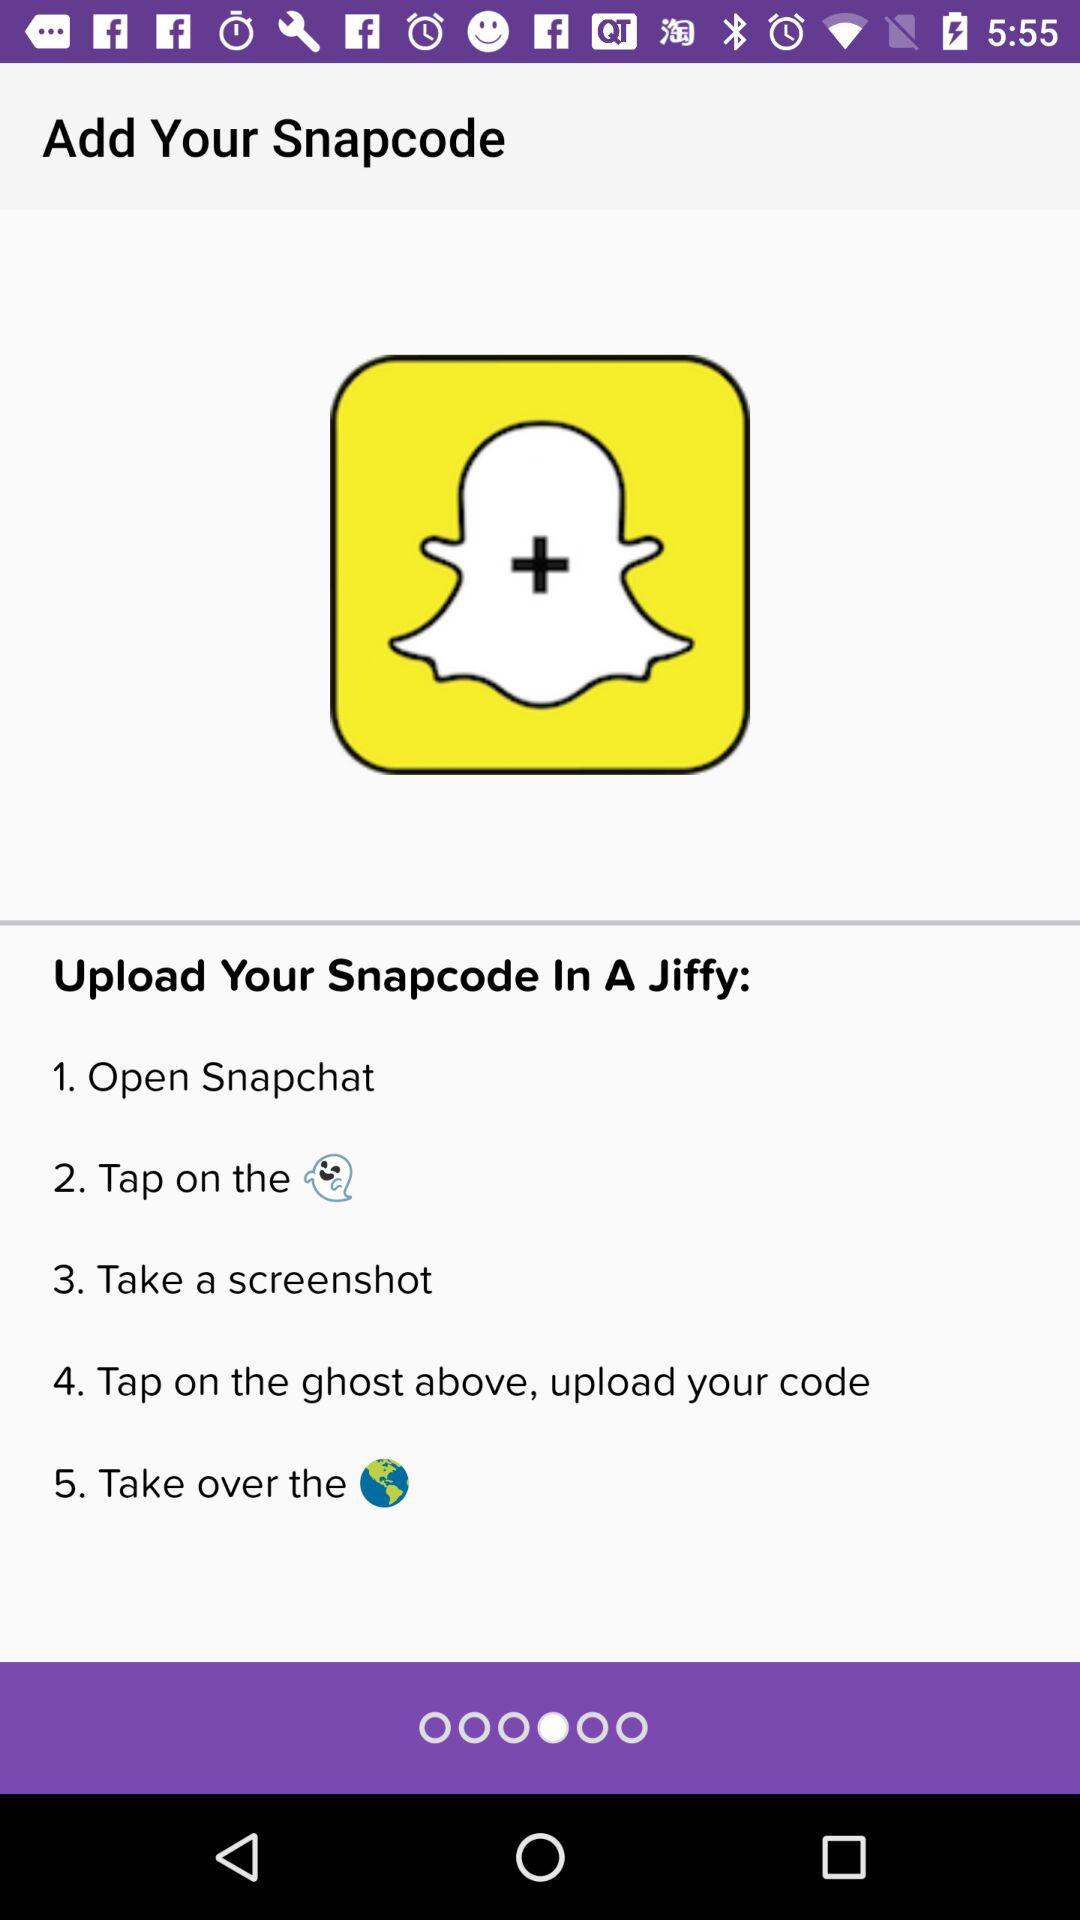How many steps are there to add your snapcode?
Answer the question using a single word or phrase. 5 